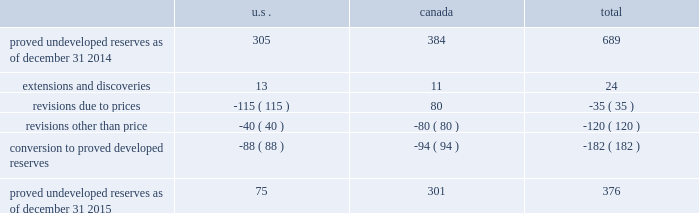Devon energy corporation and subsidiaries notes to consolidated financial statements 2013 ( continued ) proved undeveloped reserves the table presents the changes in devon 2019s total proved undeveloped reserves during 2015 ( mmboe ) . .
Proved undeveloped reserves decreased 45% ( 45 % ) from year-end 2014 to year-end 2015 , and the year-end 2015 balance represents 17% ( 17 % ) of total proved reserves .
Drilling and development activities increased devon 2019s proved undeveloped reserves 24 mmboe and resulted in the conversion of 182 mmboe , or 26% ( 26 % ) , of the 2014 proved undeveloped reserves to proved developed reserves .
Costs incurred to develop and convert devon 2019s proved undeveloped reserves were approximately $ 2.2 billion for 2015 .
Additionally , revisions other than price decreased devon 2019s proved undeveloped reserves 120 mmboe primarily due to evaluations of certain properties in the u.s .
And canada .
The largest revisions , which reduced reserves by 80 mmboe , relate to evaluations of jackfish bitumen reserves .
Of the 40 mmboe revisions recorded for u.s .
Properties , a reduction of approximately 27 mmboe represents reserves that devon now does not expect to develop in the next five years , including 20 mmboe attributable to the eagle ford .
A significant amount of devon 2019s proved undeveloped reserves at the end of 2015 related to its jackfish operations .
At december 31 , 2015 and 2014 , devon 2019s jackfish proved undeveloped reserves were 301 mmboe and 384 mmboe , respectively .
Development schedules for the jackfish reserves are primarily controlled by the need to keep the processing plants at their 35 mbbl daily facility capacity .
Processing plant capacity is controlled by factors such as total steam processing capacity and steam-oil ratios .
Furthermore , development of these projects involves the up-front construction of steam injection/distribution and bitumen processing facilities .
Due to the large up-front capital investments and large reserves required to provide economic returns , the project conditions meet the specific circumstances requiring a period greater than 5 years for conversion to developed reserves .
As a result , these reserves are classified as proved undeveloped for more than five years .
Currently , the development schedule for these reserves extends through to 2030 .
At the end of 2015 , approximately 184 mmboe of proved undeveloped reserves at jackfish have remained undeveloped for five years or more since the initial booking .
No other projects have proved undeveloped reserves that have remained undeveloped more than five years from the initial booking of the reserves .
Furthermore , approximately 180 mmboe of proved undeveloped reserves at jackfish will require in excess of five years , from the date of this filing , to develop .
Price revisions 2015 2013 reserves decreased 302 mmboe primarily due to lower commodity prices across all products .
The lower bitumen price increased canadian reserves due to the decline in royalties , which increases devon 2019s after- royalty volumes .
2014 2013 reserves increased 9 mmboe primarily due to higher gas prices in the barnett shale and the anadarko basin , partially offset by higher bitumen prices , which result in lower after-royalty volumes , in canada. .
What was the total proved reserve amount for the year-end 2015? 
Computations: (376 * (100 / 17))
Answer: 2211.76471. Devon energy corporation and subsidiaries notes to consolidated financial statements 2013 ( continued ) proved undeveloped reserves the table presents the changes in devon 2019s total proved undeveloped reserves during 2015 ( mmboe ) . .
Proved undeveloped reserves decreased 45% ( 45 % ) from year-end 2014 to year-end 2015 , and the year-end 2015 balance represents 17% ( 17 % ) of total proved reserves .
Drilling and development activities increased devon 2019s proved undeveloped reserves 24 mmboe and resulted in the conversion of 182 mmboe , or 26% ( 26 % ) , of the 2014 proved undeveloped reserves to proved developed reserves .
Costs incurred to develop and convert devon 2019s proved undeveloped reserves were approximately $ 2.2 billion for 2015 .
Additionally , revisions other than price decreased devon 2019s proved undeveloped reserves 120 mmboe primarily due to evaluations of certain properties in the u.s .
And canada .
The largest revisions , which reduced reserves by 80 mmboe , relate to evaluations of jackfish bitumen reserves .
Of the 40 mmboe revisions recorded for u.s .
Properties , a reduction of approximately 27 mmboe represents reserves that devon now does not expect to develop in the next five years , including 20 mmboe attributable to the eagle ford .
A significant amount of devon 2019s proved undeveloped reserves at the end of 2015 related to its jackfish operations .
At december 31 , 2015 and 2014 , devon 2019s jackfish proved undeveloped reserves were 301 mmboe and 384 mmboe , respectively .
Development schedules for the jackfish reserves are primarily controlled by the need to keep the processing plants at their 35 mbbl daily facility capacity .
Processing plant capacity is controlled by factors such as total steam processing capacity and steam-oil ratios .
Furthermore , development of these projects involves the up-front construction of steam injection/distribution and bitumen processing facilities .
Due to the large up-front capital investments and large reserves required to provide economic returns , the project conditions meet the specific circumstances requiring a period greater than 5 years for conversion to developed reserves .
As a result , these reserves are classified as proved undeveloped for more than five years .
Currently , the development schedule for these reserves extends through to 2030 .
At the end of 2015 , approximately 184 mmboe of proved undeveloped reserves at jackfish have remained undeveloped for five years or more since the initial booking .
No other projects have proved undeveloped reserves that have remained undeveloped more than five years from the initial booking of the reserves .
Furthermore , approximately 180 mmboe of proved undeveloped reserves at jackfish will require in excess of five years , from the date of this filing , to develop .
Price revisions 2015 2013 reserves decreased 302 mmboe primarily due to lower commodity prices across all products .
The lower bitumen price increased canadian reserves due to the decline in royalties , which increases devon 2019s after- royalty volumes .
2014 2013 reserves increased 9 mmboe primarily due to higher gas prices in the barnett shale and the anadarko basin , partially offset by higher bitumen prices , which result in lower after-royalty volumes , in canada. .
As of december 31 2014 what was the percent of the proved undeveloped reserves in the us? 
Computations: (305 / 689)
Answer: 0.44267. 